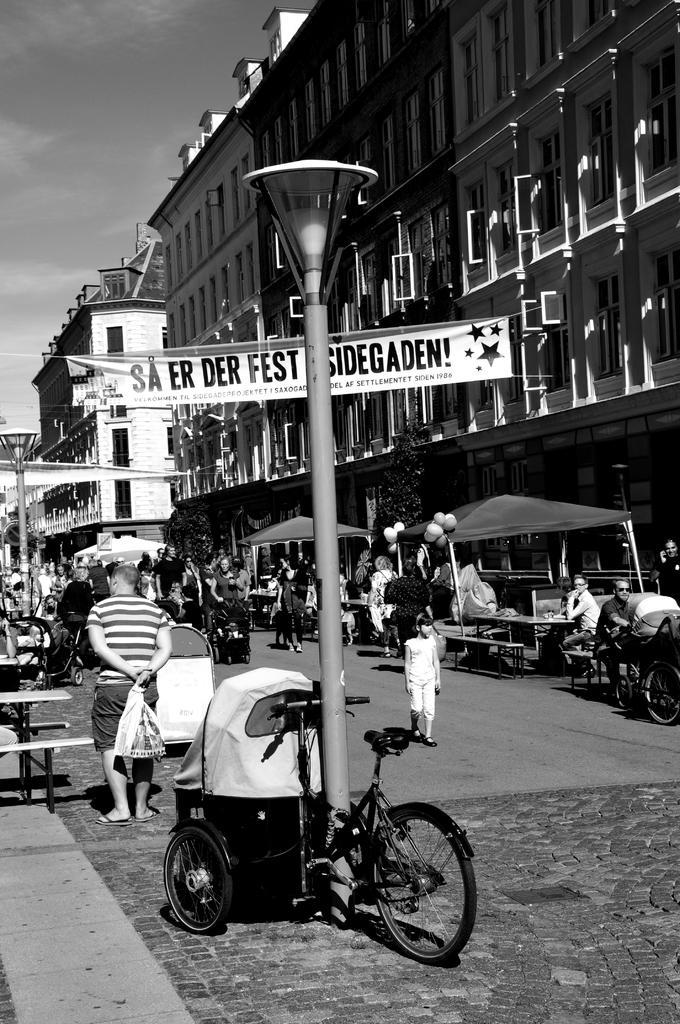Could you give a brief overview of what you see in this image? This is a black and white image. There is a building on the top and right side. There is a cycle in the middle, there is a light in the middle and there is a Banner in the middle. There are so many people in this image who are watching. There is a sky on the top left corner. 